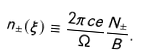Convert formula to latex. <formula><loc_0><loc_0><loc_500><loc_500>n _ { \pm } ( \xi ) \equiv \frac { 2 \pi c e } { \Omega } \frac { N _ { \pm } } { B } .</formula> 